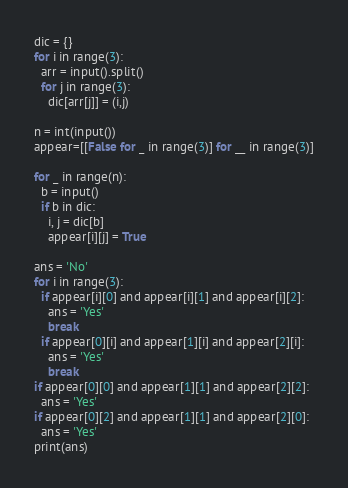Convert code to text. <code><loc_0><loc_0><loc_500><loc_500><_Python_>dic = {}
for i in range(3):
  arr = input().split()
  for j in range(3):
    dic[arr[j]] = (i,j)
    
n = int(input())
appear=[[False for _ in range(3)] for __ in range(3)]

for _ in range(n):
  b = input()
  if b in dic:
    i, j = dic[b]
    appear[i][j] = True

ans = 'No'
for i in range(3):
  if appear[i][0] and appear[i][1] and appear[i][2]:
    ans = 'Yes'
    break
  if appear[0][i] and appear[1][i] and appear[2][i]:
    ans = 'Yes'
    break
if appear[0][0] and appear[1][1] and appear[2][2]:
  ans = 'Yes'
if appear[0][2] and appear[1][1] and appear[2][0]:
  ans = 'Yes'
print(ans)
</code> 